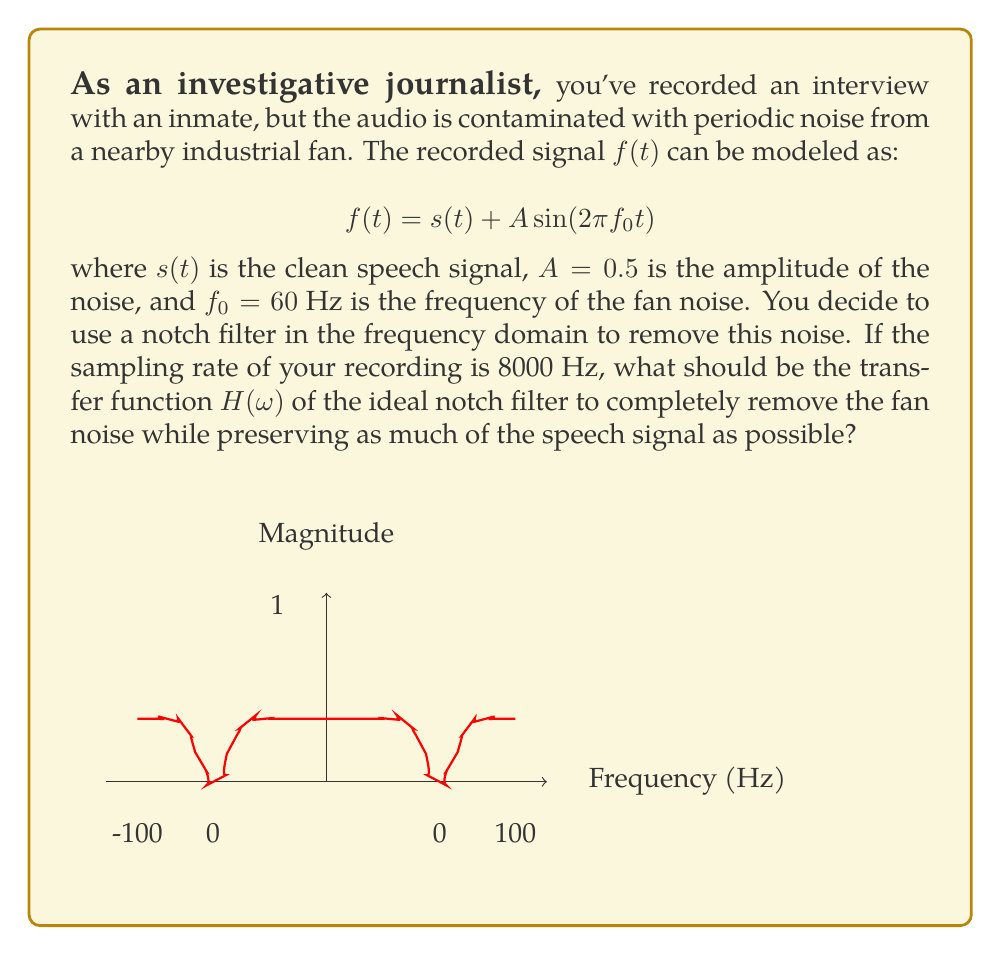Solve this math problem. Let's approach this step-by-step:

1) The fan noise is a sinusoidal component at 60 Hz. In the frequency domain, this appears as two impulses at $\pm 60$ Hz.

2) To remove this noise, we need a notch filter that removes these specific frequencies while leaving others untouched.

3) The transfer function of an ideal notch filter should have the following properties:
   - $H(\omega) = 0$ at the notch frequencies ($\pm f_0$)
   - $H(\omega) = 1$ everywhere else

4) Given the sampling rate of 8000 Hz, we need to consider the digital frequency $\omega$, which is related to the analog frequency $f$ by:

   $$\omega = 2\pi \frac{f}{f_s}$$

   where $f_s$ is the sampling frequency (8000 Hz).

5) For the fan noise at 60 Hz, the digital frequency is:

   $$\omega_0 = 2\pi \frac{60}{8000} = \frac{\pi}{66.67}$$

6) Therefore, the transfer function of the ideal notch filter should be:

   $$H(\omega) = \begin{cases} 
   0 & \text{if } \omega = \pm \frac{\pi}{66.67} \\
   1 & \text{otherwise}
   \end{cases}$$

7) This can be expressed mathematically as:

   $$H(\omega) = 1 - \delta(\omega - \frac{\pi}{66.67}) - \delta(\omega + \frac{\pi}{66.67})$$

   where $\delta(\omega)$ is the Dirac delta function.
Answer: $$H(\omega) = 1 - \delta(\omega - \frac{\pi}{66.67}) - \delta(\omega + \frac{\pi}{66.67})$$ 